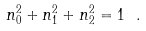<formula> <loc_0><loc_0><loc_500><loc_500>n _ { 0 } ^ { 2 } + n _ { 1 } ^ { 2 } + n _ { 2 } ^ { 2 } = 1 \ .</formula> 